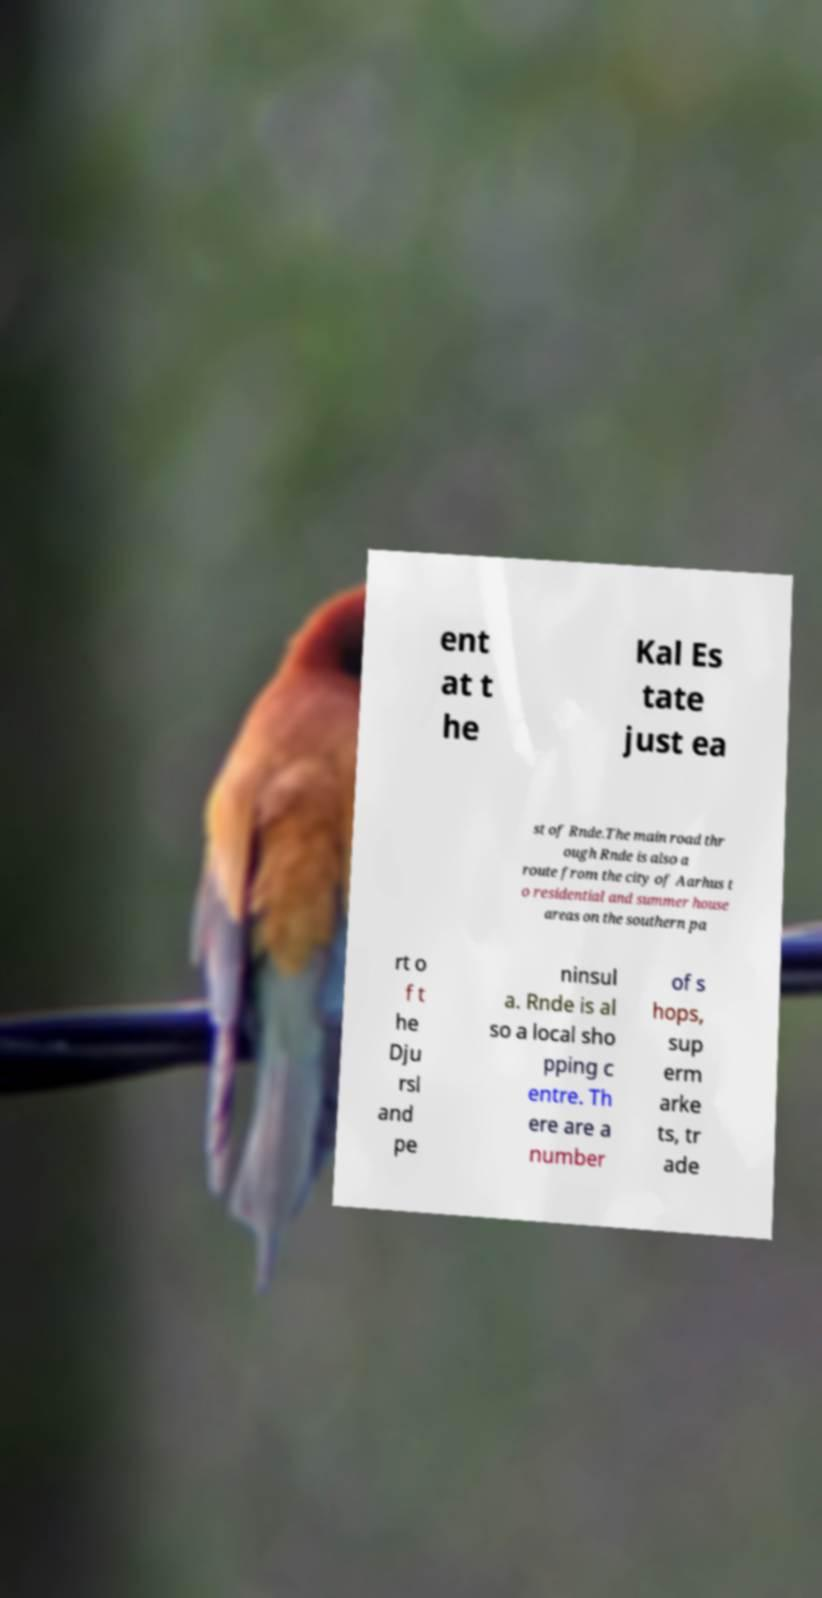I need the written content from this picture converted into text. Can you do that? ent at t he Kal Es tate just ea st of Rnde.The main road thr ough Rnde is also a route from the city of Aarhus t o residential and summer house areas on the southern pa rt o f t he Dju rsl and pe ninsul a. Rnde is al so a local sho pping c entre. Th ere are a number of s hops, sup erm arke ts, tr ade 